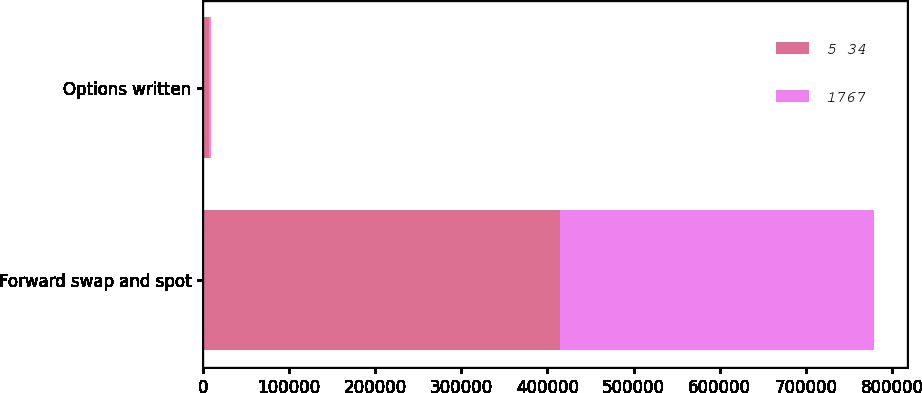Convert chart to OTSL. <chart><loc_0><loc_0><loc_500><loc_500><stacked_bar_chart><ecel><fcel>Forward swap and spot<fcel>Options written<nl><fcel>5 34<fcel>414376<fcel>6763<nl><fcel>1767<fcel>364357<fcel>3214<nl></chart> 